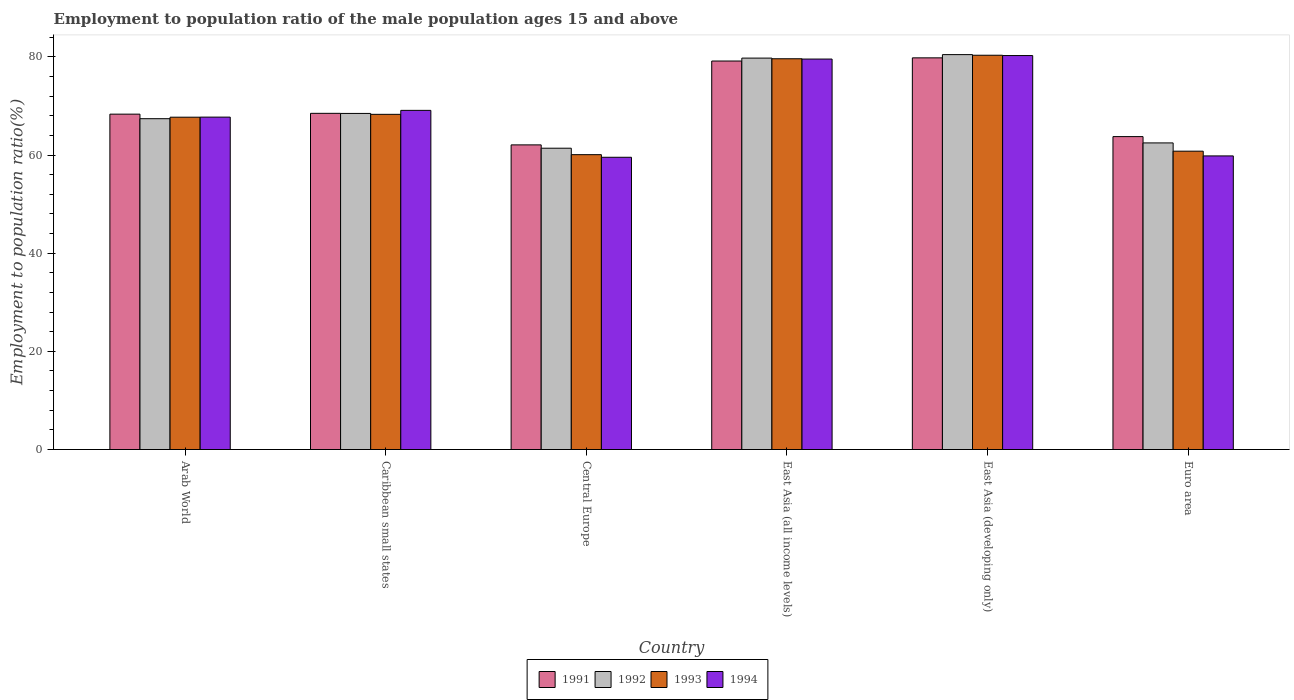Are the number of bars on each tick of the X-axis equal?
Offer a very short reply. Yes. How many bars are there on the 4th tick from the left?
Your answer should be very brief. 4. How many bars are there on the 5th tick from the right?
Your response must be concise. 4. What is the label of the 2nd group of bars from the left?
Your answer should be compact. Caribbean small states. In how many cases, is the number of bars for a given country not equal to the number of legend labels?
Your answer should be very brief. 0. What is the employment to population ratio in 1993 in Central Europe?
Keep it short and to the point. 60.07. Across all countries, what is the maximum employment to population ratio in 1992?
Your answer should be compact. 80.45. Across all countries, what is the minimum employment to population ratio in 1991?
Provide a succinct answer. 62.06. In which country was the employment to population ratio in 1992 maximum?
Make the answer very short. East Asia (developing only). In which country was the employment to population ratio in 1992 minimum?
Offer a terse response. Central Europe. What is the total employment to population ratio in 1993 in the graph?
Your answer should be compact. 416.77. What is the difference between the employment to population ratio in 1994 in Caribbean small states and that in Euro area?
Provide a succinct answer. 9.28. What is the difference between the employment to population ratio in 1994 in Euro area and the employment to population ratio in 1993 in Arab World?
Your answer should be compact. -7.89. What is the average employment to population ratio in 1991 per country?
Make the answer very short. 70.26. What is the difference between the employment to population ratio of/in 1993 and employment to population ratio of/in 1992 in East Asia (all income levels)?
Your response must be concise. -0.13. What is the ratio of the employment to population ratio in 1993 in Caribbean small states to that in Euro area?
Your answer should be compact. 1.12. Is the difference between the employment to population ratio in 1993 in Arab World and East Asia (developing only) greater than the difference between the employment to population ratio in 1992 in Arab World and East Asia (developing only)?
Offer a terse response. Yes. What is the difference between the highest and the second highest employment to population ratio in 1993?
Your answer should be compact. 12.04. What is the difference between the highest and the lowest employment to population ratio in 1991?
Offer a very short reply. 17.73. In how many countries, is the employment to population ratio in 1993 greater than the average employment to population ratio in 1993 taken over all countries?
Your answer should be very brief. 2. Is the sum of the employment to population ratio in 1994 in Arab World and Central Europe greater than the maximum employment to population ratio in 1993 across all countries?
Offer a very short reply. Yes. Is it the case that in every country, the sum of the employment to population ratio in 1994 and employment to population ratio in 1993 is greater than the sum of employment to population ratio in 1991 and employment to population ratio in 1992?
Your answer should be compact. No. What does the 1st bar from the left in East Asia (all income levels) represents?
Make the answer very short. 1991. How many bars are there?
Ensure brevity in your answer.  24. Are all the bars in the graph horizontal?
Give a very brief answer. No. How many countries are there in the graph?
Keep it short and to the point. 6. What is the difference between two consecutive major ticks on the Y-axis?
Make the answer very short. 20. Does the graph contain grids?
Provide a succinct answer. No. What is the title of the graph?
Offer a very short reply. Employment to population ratio of the male population ages 15 and above. What is the label or title of the X-axis?
Keep it short and to the point. Country. What is the label or title of the Y-axis?
Your answer should be compact. Employment to population ratio(%). What is the Employment to population ratio(%) in 1991 in Arab World?
Offer a terse response. 68.32. What is the Employment to population ratio(%) of 1992 in Arab World?
Offer a very short reply. 67.4. What is the Employment to population ratio(%) of 1993 in Arab World?
Give a very brief answer. 67.7. What is the Employment to population ratio(%) in 1994 in Arab World?
Your answer should be compact. 67.72. What is the Employment to population ratio(%) in 1991 in Caribbean small states?
Your answer should be very brief. 68.49. What is the Employment to population ratio(%) in 1992 in Caribbean small states?
Ensure brevity in your answer.  68.47. What is the Employment to population ratio(%) of 1993 in Caribbean small states?
Provide a succinct answer. 68.28. What is the Employment to population ratio(%) in 1994 in Caribbean small states?
Make the answer very short. 69.09. What is the Employment to population ratio(%) of 1991 in Central Europe?
Offer a very short reply. 62.06. What is the Employment to population ratio(%) in 1992 in Central Europe?
Offer a very short reply. 61.38. What is the Employment to population ratio(%) in 1993 in Central Europe?
Offer a very short reply. 60.07. What is the Employment to population ratio(%) of 1994 in Central Europe?
Keep it short and to the point. 59.54. What is the Employment to population ratio(%) of 1991 in East Asia (all income levels)?
Your response must be concise. 79.15. What is the Employment to population ratio(%) of 1992 in East Asia (all income levels)?
Make the answer very short. 79.74. What is the Employment to population ratio(%) of 1993 in East Asia (all income levels)?
Provide a succinct answer. 79.61. What is the Employment to population ratio(%) in 1994 in East Asia (all income levels)?
Give a very brief answer. 79.55. What is the Employment to population ratio(%) of 1991 in East Asia (developing only)?
Provide a succinct answer. 79.79. What is the Employment to population ratio(%) of 1992 in East Asia (developing only)?
Your response must be concise. 80.45. What is the Employment to population ratio(%) of 1993 in East Asia (developing only)?
Provide a succinct answer. 80.32. What is the Employment to population ratio(%) of 1994 in East Asia (developing only)?
Offer a very short reply. 80.26. What is the Employment to population ratio(%) of 1991 in Euro area?
Your answer should be very brief. 63.75. What is the Employment to population ratio(%) of 1992 in Euro area?
Your answer should be very brief. 62.46. What is the Employment to population ratio(%) of 1993 in Euro area?
Offer a very short reply. 60.78. What is the Employment to population ratio(%) of 1994 in Euro area?
Offer a terse response. 59.81. Across all countries, what is the maximum Employment to population ratio(%) of 1991?
Provide a succinct answer. 79.79. Across all countries, what is the maximum Employment to population ratio(%) in 1992?
Ensure brevity in your answer.  80.45. Across all countries, what is the maximum Employment to population ratio(%) of 1993?
Offer a very short reply. 80.32. Across all countries, what is the maximum Employment to population ratio(%) of 1994?
Make the answer very short. 80.26. Across all countries, what is the minimum Employment to population ratio(%) in 1991?
Give a very brief answer. 62.06. Across all countries, what is the minimum Employment to population ratio(%) of 1992?
Ensure brevity in your answer.  61.38. Across all countries, what is the minimum Employment to population ratio(%) of 1993?
Give a very brief answer. 60.07. Across all countries, what is the minimum Employment to population ratio(%) of 1994?
Your response must be concise. 59.54. What is the total Employment to population ratio(%) of 1991 in the graph?
Your response must be concise. 421.57. What is the total Employment to population ratio(%) of 1992 in the graph?
Your response must be concise. 419.91. What is the total Employment to population ratio(%) of 1993 in the graph?
Your answer should be compact. 416.77. What is the total Employment to population ratio(%) of 1994 in the graph?
Offer a very short reply. 415.97. What is the difference between the Employment to population ratio(%) of 1991 in Arab World and that in Caribbean small states?
Your response must be concise. -0.17. What is the difference between the Employment to population ratio(%) of 1992 in Arab World and that in Caribbean small states?
Provide a short and direct response. -1.07. What is the difference between the Employment to population ratio(%) in 1993 in Arab World and that in Caribbean small states?
Provide a succinct answer. -0.58. What is the difference between the Employment to population ratio(%) in 1994 in Arab World and that in Caribbean small states?
Your answer should be compact. -1.38. What is the difference between the Employment to population ratio(%) in 1991 in Arab World and that in Central Europe?
Ensure brevity in your answer.  6.26. What is the difference between the Employment to population ratio(%) of 1992 in Arab World and that in Central Europe?
Offer a terse response. 6.01. What is the difference between the Employment to population ratio(%) of 1993 in Arab World and that in Central Europe?
Your response must be concise. 7.63. What is the difference between the Employment to population ratio(%) in 1994 in Arab World and that in Central Europe?
Provide a short and direct response. 8.18. What is the difference between the Employment to population ratio(%) in 1991 in Arab World and that in East Asia (all income levels)?
Your answer should be very brief. -10.82. What is the difference between the Employment to population ratio(%) in 1992 in Arab World and that in East Asia (all income levels)?
Your response must be concise. -12.34. What is the difference between the Employment to population ratio(%) in 1993 in Arab World and that in East Asia (all income levels)?
Make the answer very short. -11.9. What is the difference between the Employment to population ratio(%) in 1994 in Arab World and that in East Asia (all income levels)?
Give a very brief answer. -11.83. What is the difference between the Employment to population ratio(%) of 1991 in Arab World and that in East Asia (developing only)?
Offer a very short reply. -11.47. What is the difference between the Employment to population ratio(%) of 1992 in Arab World and that in East Asia (developing only)?
Your answer should be very brief. -13.05. What is the difference between the Employment to population ratio(%) of 1993 in Arab World and that in East Asia (developing only)?
Provide a short and direct response. -12.62. What is the difference between the Employment to population ratio(%) of 1994 in Arab World and that in East Asia (developing only)?
Give a very brief answer. -12.54. What is the difference between the Employment to population ratio(%) of 1991 in Arab World and that in Euro area?
Your answer should be very brief. 4.58. What is the difference between the Employment to population ratio(%) in 1992 in Arab World and that in Euro area?
Your answer should be compact. 4.94. What is the difference between the Employment to population ratio(%) in 1993 in Arab World and that in Euro area?
Your answer should be compact. 6.92. What is the difference between the Employment to population ratio(%) of 1994 in Arab World and that in Euro area?
Give a very brief answer. 7.9. What is the difference between the Employment to population ratio(%) in 1991 in Caribbean small states and that in Central Europe?
Provide a succinct answer. 6.43. What is the difference between the Employment to population ratio(%) in 1992 in Caribbean small states and that in Central Europe?
Keep it short and to the point. 7.09. What is the difference between the Employment to population ratio(%) of 1993 in Caribbean small states and that in Central Europe?
Provide a succinct answer. 8.21. What is the difference between the Employment to population ratio(%) in 1994 in Caribbean small states and that in Central Europe?
Keep it short and to the point. 9.56. What is the difference between the Employment to population ratio(%) in 1991 in Caribbean small states and that in East Asia (all income levels)?
Keep it short and to the point. -10.66. What is the difference between the Employment to population ratio(%) of 1992 in Caribbean small states and that in East Asia (all income levels)?
Give a very brief answer. -11.27. What is the difference between the Employment to population ratio(%) in 1993 in Caribbean small states and that in East Asia (all income levels)?
Offer a very short reply. -11.32. What is the difference between the Employment to population ratio(%) of 1994 in Caribbean small states and that in East Asia (all income levels)?
Offer a very short reply. -10.45. What is the difference between the Employment to population ratio(%) in 1991 in Caribbean small states and that in East Asia (developing only)?
Keep it short and to the point. -11.3. What is the difference between the Employment to population ratio(%) in 1992 in Caribbean small states and that in East Asia (developing only)?
Give a very brief answer. -11.98. What is the difference between the Employment to population ratio(%) of 1993 in Caribbean small states and that in East Asia (developing only)?
Make the answer very short. -12.04. What is the difference between the Employment to population ratio(%) of 1994 in Caribbean small states and that in East Asia (developing only)?
Ensure brevity in your answer.  -11.17. What is the difference between the Employment to population ratio(%) in 1991 in Caribbean small states and that in Euro area?
Make the answer very short. 4.74. What is the difference between the Employment to population ratio(%) in 1992 in Caribbean small states and that in Euro area?
Offer a very short reply. 6.01. What is the difference between the Employment to population ratio(%) in 1993 in Caribbean small states and that in Euro area?
Offer a very short reply. 7.5. What is the difference between the Employment to population ratio(%) in 1994 in Caribbean small states and that in Euro area?
Your answer should be compact. 9.28. What is the difference between the Employment to population ratio(%) of 1991 in Central Europe and that in East Asia (all income levels)?
Offer a very short reply. -17.08. What is the difference between the Employment to population ratio(%) in 1992 in Central Europe and that in East Asia (all income levels)?
Your response must be concise. -18.36. What is the difference between the Employment to population ratio(%) of 1993 in Central Europe and that in East Asia (all income levels)?
Your response must be concise. -19.54. What is the difference between the Employment to population ratio(%) in 1994 in Central Europe and that in East Asia (all income levels)?
Your response must be concise. -20.01. What is the difference between the Employment to population ratio(%) in 1991 in Central Europe and that in East Asia (developing only)?
Give a very brief answer. -17.73. What is the difference between the Employment to population ratio(%) in 1992 in Central Europe and that in East Asia (developing only)?
Your response must be concise. -19.07. What is the difference between the Employment to population ratio(%) of 1993 in Central Europe and that in East Asia (developing only)?
Make the answer very short. -20.25. What is the difference between the Employment to population ratio(%) of 1994 in Central Europe and that in East Asia (developing only)?
Make the answer very short. -20.72. What is the difference between the Employment to population ratio(%) in 1991 in Central Europe and that in Euro area?
Keep it short and to the point. -1.69. What is the difference between the Employment to population ratio(%) of 1992 in Central Europe and that in Euro area?
Give a very brief answer. -1.08. What is the difference between the Employment to population ratio(%) of 1993 in Central Europe and that in Euro area?
Make the answer very short. -0.71. What is the difference between the Employment to population ratio(%) of 1994 in Central Europe and that in Euro area?
Make the answer very short. -0.28. What is the difference between the Employment to population ratio(%) in 1991 in East Asia (all income levels) and that in East Asia (developing only)?
Offer a terse response. -0.65. What is the difference between the Employment to population ratio(%) of 1992 in East Asia (all income levels) and that in East Asia (developing only)?
Provide a short and direct response. -0.71. What is the difference between the Employment to population ratio(%) of 1993 in East Asia (all income levels) and that in East Asia (developing only)?
Provide a succinct answer. -0.72. What is the difference between the Employment to population ratio(%) in 1994 in East Asia (all income levels) and that in East Asia (developing only)?
Offer a very short reply. -0.71. What is the difference between the Employment to population ratio(%) of 1991 in East Asia (all income levels) and that in Euro area?
Your response must be concise. 15.4. What is the difference between the Employment to population ratio(%) of 1992 in East Asia (all income levels) and that in Euro area?
Offer a very short reply. 17.28. What is the difference between the Employment to population ratio(%) in 1993 in East Asia (all income levels) and that in Euro area?
Give a very brief answer. 18.83. What is the difference between the Employment to population ratio(%) in 1994 in East Asia (all income levels) and that in Euro area?
Your response must be concise. 19.73. What is the difference between the Employment to population ratio(%) in 1991 in East Asia (developing only) and that in Euro area?
Offer a terse response. 16.05. What is the difference between the Employment to population ratio(%) of 1992 in East Asia (developing only) and that in Euro area?
Give a very brief answer. 17.99. What is the difference between the Employment to population ratio(%) in 1993 in East Asia (developing only) and that in Euro area?
Ensure brevity in your answer.  19.54. What is the difference between the Employment to population ratio(%) in 1994 in East Asia (developing only) and that in Euro area?
Your response must be concise. 20.45. What is the difference between the Employment to population ratio(%) of 1991 in Arab World and the Employment to population ratio(%) of 1992 in Caribbean small states?
Offer a terse response. -0.15. What is the difference between the Employment to population ratio(%) in 1991 in Arab World and the Employment to population ratio(%) in 1993 in Caribbean small states?
Ensure brevity in your answer.  0.04. What is the difference between the Employment to population ratio(%) in 1991 in Arab World and the Employment to population ratio(%) in 1994 in Caribbean small states?
Ensure brevity in your answer.  -0.77. What is the difference between the Employment to population ratio(%) of 1992 in Arab World and the Employment to population ratio(%) of 1993 in Caribbean small states?
Ensure brevity in your answer.  -0.89. What is the difference between the Employment to population ratio(%) in 1992 in Arab World and the Employment to population ratio(%) in 1994 in Caribbean small states?
Your response must be concise. -1.7. What is the difference between the Employment to population ratio(%) of 1993 in Arab World and the Employment to population ratio(%) of 1994 in Caribbean small states?
Your answer should be very brief. -1.39. What is the difference between the Employment to population ratio(%) in 1991 in Arab World and the Employment to population ratio(%) in 1992 in Central Europe?
Your response must be concise. 6.94. What is the difference between the Employment to population ratio(%) in 1991 in Arab World and the Employment to population ratio(%) in 1993 in Central Europe?
Ensure brevity in your answer.  8.25. What is the difference between the Employment to population ratio(%) in 1991 in Arab World and the Employment to population ratio(%) in 1994 in Central Europe?
Ensure brevity in your answer.  8.79. What is the difference between the Employment to population ratio(%) in 1992 in Arab World and the Employment to population ratio(%) in 1993 in Central Europe?
Offer a very short reply. 7.33. What is the difference between the Employment to population ratio(%) of 1992 in Arab World and the Employment to population ratio(%) of 1994 in Central Europe?
Provide a succinct answer. 7.86. What is the difference between the Employment to population ratio(%) of 1993 in Arab World and the Employment to population ratio(%) of 1994 in Central Europe?
Offer a very short reply. 8.17. What is the difference between the Employment to population ratio(%) of 1991 in Arab World and the Employment to population ratio(%) of 1992 in East Asia (all income levels)?
Keep it short and to the point. -11.42. What is the difference between the Employment to population ratio(%) of 1991 in Arab World and the Employment to population ratio(%) of 1993 in East Asia (all income levels)?
Your answer should be compact. -11.28. What is the difference between the Employment to population ratio(%) of 1991 in Arab World and the Employment to population ratio(%) of 1994 in East Asia (all income levels)?
Provide a short and direct response. -11.22. What is the difference between the Employment to population ratio(%) in 1992 in Arab World and the Employment to population ratio(%) in 1993 in East Asia (all income levels)?
Your answer should be very brief. -12.21. What is the difference between the Employment to population ratio(%) in 1992 in Arab World and the Employment to population ratio(%) in 1994 in East Asia (all income levels)?
Provide a short and direct response. -12.15. What is the difference between the Employment to population ratio(%) in 1993 in Arab World and the Employment to population ratio(%) in 1994 in East Asia (all income levels)?
Your answer should be very brief. -11.84. What is the difference between the Employment to population ratio(%) in 1991 in Arab World and the Employment to population ratio(%) in 1992 in East Asia (developing only)?
Your response must be concise. -12.13. What is the difference between the Employment to population ratio(%) of 1991 in Arab World and the Employment to population ratio(%) of 1993 in East Asia (developing only)?
Ensure brevity in your answer.  -12. What is the difference between the Employment to population ratio(%) of 1991 in Arab World and the Employment to population ratio(%) of 1994 in East Asia (developing only)?
Ensure brevity in your answer.  -11.94. What is the difference between the Employment to population ratio(%) of 1992 in Arab World and the Employment to population ratio(%) of 1993 in East Asia (developing only)?
Keep it short and to the point. -12.93. What is the difference between the Employment to population ratio(%) in 1992 in Arab World and the Employment to population ratio(%) in 1994 in East Asia (developing only)?
Provide a short and direct response. -12.86. What is the difference between the Employment to population ratio(%) of 1993 in Arab World and the Employment to population ratio(%) of 1994 in East Asia (developing only)?
Your answer should be compact. -12.56. What is the difference between the Employment to population ratio(%) in 1991 in Arab World and the Employment to population ratio(%) in 1992 in Euro area?
Your answer should be compact. 5.86. What is the difference between the Employment to population ratio(%) of 1991 in Arab World and the Employment to population ratio(%) of 1993 in Euro area?
Keep it short and to the point. 7.54. What is the difference between the Employment to population ratio(%) in 1991 in Arab World and the Employment to population ratio(%) in 1994 in Euro area?
Give a very brief answer. 8.51. What is the difference between the Employment to population ratio(%) in 1992 in Arab World and the Employment to population ratio(%) in 1993 in Euro area?
Ensure brevity in your answer.  6.62. What is the difference between the Employment to population ratio(%) in 1992 in Arab World and the Employment to population ratio(%) in 1994 in Euro area?
Offer a very short reply. 7.58. What is the difference between the Employment to population ratio(%) in 1993 in Arab World and the Employment to population ratio(%) in 1994 in Euro area?
Offer a terse response. 7.89. What is the difference between the Employment to population ratio(%) of 1991 in Caribbean small states and the Employment to population ratio(%) of 1992 in Central Europe?
Offer a very short reply. 7.11. What is the difference between the Employment to population ratio(%) in 1991 in Caribbean small states and the Employment to population ratio(%) in 1993 in Central Europe?
Your response must be concise. 8.42. What is the difference between the Employment to population ratio(%) of 1991 in Caribbean small states and the Employment to population ratio(%) of 1994 in Central Europe?
Your answer should be very brief. 8.95. What is the difference between the Employment to population ratio(%) of 1992 in Caribbean small states and the Employment to population ratio(%) of 1993 in Central Europe?
Your answer should be very brief. 8.4. What is the difference between the Employment to population ratio(%) of 1992 in Caribbean small states and the Employment to population ratio(%) of 1994 in Central Europe?
Ensure brevity in your answer.  8.93. What is the difference between the Employment to population ratio(%) in 1993 in Caribbean small states and the Employment to population ratio(%) in 1994 in Central Europe?
Keep it short and to the point. 8.75. What is the difference between the Employment to population ratio(%) in 1991 in Caribbean small states and the Employment to population ratio(%) in 1992 in East Asia (all income levels)?
Your response must be concise. -11.25. What is the difference between the Employment to population ratio(%) of 1991 in Caribbean small states and the Employment to population ratio(%) of 1993 in East Asia (all income levels)?
Give a very brief answer. -11.12. What is the difference between the Employment to population ratio(%) of 1991 in Caribbean small states and the Employment to population ratio(%) of 1994 in East Asia (all income levels)?
Make the answer very short. -11.06. What is the difference between the Employment to population ratio(%) of 1992 in Caribbean small states and the Employment to population ratio(%) of 1993 in East Asia (all income levels)?
Make the answer very short. -11.14. What is the difference between the Employment to population ratio(%) of 1992 in Caribbean small states and the Employment to population ratio(%) of 1994 in East Asia (all income levels)?
Offer a terse response. -11.08. What is the difference between the Employment to population ratio(%) of 1993 in Caribbean small states and the Employment to population ratio(%) of 1994 in East Asia (all income levels)?
Keep it short and to the point. -11.26. What is the difference between the Employment to population ratio(%) in 1991 in Caribbean small states and the Employment to population ratio(%) in 1992 in East Asia (developing only)?
Provide a short and direct response. -11.96. What is the difference between the Employment to population ratio(%) in 1991 in Caribbean small states and the Employment to population ratio(%) in 1993 in East Asia (developing only)?
Ensure brevity in your answer.  -11.83. What is the difference between the Employment to population ratio(%) of 1991 in Caribbean small states and the Employment to population ratio(%) of 1994 in East Asia (developing only)?
Offer a very short reply. -11.77. What is the difference between the Employment to population ratio(%) in 1992 in Caribbean small states and the Employment to population ratio(%) in 1993 in East Asia (developing only)?
Your response must be concise. -11.85. What is the difference between the Employment to population ratio(%) in 1992 in Caribbean small states and the Employment to population ratio(%) in 1994 in East Asia (developing only)?
Provide a short and direct response. -11.79. What is the difference between the Employment to population ratio(%) in 1993 in Caribbean small states and the Employment to population ratio(%) in 1994 in East Asia (developing only)?
Make the answer very short. -11.98. What is the difference between the Employment to population ratio(%) in 1991 in Caribbean small states and the Employment to population ratio(%) in 1992 in Euro area?
Your answer should be very brief. 6.03. What is the difference between the Employment to population ratio(%) of 1991 in Caribbean small states and the Employment to population ratio(%) of 1993 in Euro area?
Offer a very short reply. 7.71. What is the difference between the Employment to population ratio(%) in 1991 in Caribbean small states and the Employment to population ratio(%) in 1994 in Euro area?
Offer a very short reply. 8.68. What is the difference between the Employment to population ratio(%) of 1992 in Caribbean small states and the Employment to population ratio(%) of 1993 in Euro area?
Your answer should be very brief. 7.69. What is the difference between the Employment to population ratio(%) in 1992 in Caribbean small states and the Employment to population ratio(%) in 1994 in Euro area?
Your response must be concise. 8.66. What is the difference between the Employment to population ratio(%) of 1993 in Caribbean small states and the Employment to population ratio(%) of 1994 in Euro area?
Make the answer very short. 8.47. What is the difference between the Employment to population ratio(%) in 1991 in Central Europe and the Employment to population ratio(%) in 1992 in East Asia (all income levels)?
Offer a terse response. -17.68. What is the difference between the Employment to population ratio(%) of 1991 in Central Europe and the Employment to population ratio(%) of 1993 in East Asia (all income levels)?
Provide a succinct answer. -17.55. What is the difference between the Employment to population ratio(%) of 1991 in Central Europe and the Employment to population ratio(%) of 1994 in East Asia (all income levels)?
Provide a succinct answer. -17.49. What is the difference between the Employment to population ratio(%) in 1992 in Central Europe and the Employment to population ratio(%) in 1993 in East Asia (all income levels)?
Offer a terse response. -18.22. What is the difference between the Employment to population ratio(%) of 1992 in Central Europe and the Employment to population ratio(%) of 1994 in East Asia (all income levels)?
Make the answer very short. -18.16. What is the difference between the Employment to population ratio(%) in 1993 in Central Europe and the Employment to population ratio(%) in 1994 in East Asia (all income levels)?
Your answer should be compact. -19.48. What is the difference between the Employment to population ratio(%) of 1991 in Central Europe and the Employment to population ratio(%) of 1992 in East Asia (developing only)?
Give a very brief answer. -18.39. What is the difference between the Employment to population ratio(%) in 1991 in Central Europe and the Employment to population ratio(%) in 1993 in East Asia (developing only)?
Ensure brevity in your answer.  -18.26. What is the difference between the Employment to population ratio(%) in 1991 in Central Europe and the Employment to population ratio(%) in 1994 in East Asia (developing only)?
Ensure brevity in your answer.  -18.2. What is the difference between the Employment to population ratio(%) in 1992 in Central Europe and the Employment to population ratio(%) in 1993 in East Asia (developing only)?
Give a very brief answer. -18.94. What is the difference between the Employment to population ratio(%) in 1992 in Central Europe and the Employment to population ratio(%) in 1994 in East Asia (developing only)?
Keep it short and to the point. -18.88. What is the difference between the Employment to population ratio(%) of 1993 in Central Europe and the Employment to population ratio(%) of 1994 in East Asia (developing only)?
Your answer should be compact. -20.19. What is the difference between the Employment to population ratio(%) of 1991 in Central Europe and the Employment to population ratio(%) of 1992 in Euro area?
Offer a terse response. -0.4. What is the difference between the Employment to population ratio(%) in 1991 in Central Europe and the Employment to population ratio(%) in 1993 in Euro area?
Offer a very short reply. 1.28. What is the difference between the Employment to population ratio(%) in 1991 in Central Europe and the Employment to population ratio(%) in 1994 in Euro area?
Give a very brief answer. 2.25. What is the difference between the Employment to population ratio(%) in 1992 in Central Europe and the Employment to population ratio(%) in 1993 in Euro area?
Give a very brief answer. 0.6. What is the difference between the Employment to population ratio(%) in 1992 in Central Europe and the Employment to population ratio(%) in 1994 in Euro area?
Offer a very short reply. 1.57. What is the difference between the Employment to population ratio(%) of 1993 in Central Europe and the Employment to population ratio(%) of 1994 in Euro area?
Ensure brevity in your answer.  0.26. What is the difference between the Employment to population ratio(%) of 1991 in East Asia (all income levels) and the Employment to population ratio(%) of 1992 in East Asia (developing only)?
Offer a very short reply. -1.3. What is the difference between the Employment to population ratio(%) of 1991 in East Asia (all income levels) and the Employment to population ratio(%) of 1993 in East Asia (developing only)?
Give a very brief answer. -1.18. What is the difference between the Employment to population ratio(%) in 1991 in East Asia (all income levels) and the Employment to population ratio(%) in 1994 in East Asia (developing only)?
Your response must be concise. -1.11. What is the difference between the Employment to population ratio(%) in 1992 in East Asia (all income levels) and the Employment to population ratio(%) in 1993 in East Asia (developing only)?
Your answer should be very brief. -0.58. What is the difference between the Employment to population ratio(%) of 1992 in East Asia (all income levels) and the Employment to population ratio(%) of 1994 in East Asia (developing only)?
Offer a very short reply. -0.52. What is the difference between the Employment to population ratio(%) of 1993 in East Asia (all income levels) and the Employment to population ratio(%) of 1994 in East Asia (developing only)?
Keep it short and to the point. -0.65. What is the difference between the Employment to population ratio(%) of 1991 in East Asia (all income levels) and the Employment to population ratio(%) of 1992 in Euro area?
Keep it short and to the point. 16.68. What is the difference between the Employment to population ratio(%) of 1991 in East Asia (all income levels) and the Employment to population ratio(%) of 1993 in Euro area?
Offer a terse response. 18.37. What is the difference between the Employment to population ratio(%) of 1991 in East Asia (all income levels) and the Employment to population ratio(%) of 1994 in Euro area?
Offer a terse response. 19.33. What is the difference between the Employment to population ratio(%) in 1992 in East Asia (all income levels) and the Employment to population ratio(%) in 1993 in Euro area?
Provide a short and direct response. 18.96. What is the difference between the Employment to population ratio(%) of 1992 in East Asia (all income levels) and the Employment to population ratio(%) of 1994 in Euro area?
Your answer should be very brief. 19.93. What is the difference between the Employment to population ratio(%) in 1993 in East Asia (all income levels) and the Employment to population ratio(%) in 1994 in Euro area?
Provide a succinct answer. 19.79. What is the difference between the Employment to population ratio(%) of 1991 in East Asia (developing only) and the Employment to population ratio(%) of 1992 in Euro area?
Provide a short and direct response. 17.33. What is the difference between the Employment to population ratio(%) of 1991 in East Asia (developing only) and the Employment to population ratio(%) of 1993 in Euro area?
Offer a very short reply. 19.01. What is the difference between the Employment to population ratio(%) in 1991 in East Asia (developing only) and the Employment to population ratio(%) in 1994 in Euro area?
Give a very brief answer. 19.98. What is the difference between the Employment to population ratio(%) in 1992 in East Asia (developing only) and the Employment to population ratio(%) in 1993 in Euro area?
Ensure brevity in your answer.  19.67. What is the difference between the Employment to population ratio(%) of 1992 in East Asia (developing only) and the Employment to population ratio(%) of 1994 in Euro area?
Give a very brief answer. 20.64. What is the difference between the Employment to population ratio(%) in 1993 in East Asia (developing only) and the Employment to population ratio(%) in 1994 in Euro area?
Offer a terse response. 20.51. What is the average Employment to population ratio(%) of 1991 per country?
Keep it short and to the point. 70.26. What is the average Employment to population ratio(%) of 1992 per country?
Give a very brief answer. 69.98. What is the average Employment to population ratio(%) in 1993 per country?
Ensure brevity in your answer.  69.46. What is the average Employment to population ratio(%) in 1994 per country?
Offer a terse response. 69.33. What is the difference between the Employment to population ratio(%) of 1991 and Employment to population ratio(%) of 1992 in Arab World?
Make the answer very short. 0.93. What is the difference between the Employment to population ratio(%) of 1991 and Employment to population ratio(%) of 1993 in Arab World?
Offer a terse response. 0.62. What is the difference between the Employment to population ratio(%) in 1991 and Employment to population ratio(%) in 1994 in Arab World?
Ensure brevity in your answer.  0.61. What is the difference between the Employment to population ratio(%) in 1992 and Employment to population ratio(%) in 1993 in Arab World?
Make the answer very short. -0.31. What is the difference between the Employment to population ratio(%) in 1992 and Employment to population ratio(%) in 1994 in Arab World?
Your answer should be compact. -0.32. What is the difference between the Employment to population ratio(%) of 1993 and Employment to population ratio(%) of 1994 in Arab World?
Your response must be concise. -0.01. What is the difference between the Employment to population ratio(%) of 1991 and Employment to population ratio(%) of 1992 in Caribbean small states?
Offer a very short reply. 0.02. What is the difference between the Employment to population ratio(%) in 1991 and Employment to population ratio(%) in 1993 in Caribbean small states?
Keep it short and to the point. 0.21. What is the difference between the Employment to population ratio(%) in 1991 and Employment to population ratio(%) in 1994 in Caribbean small states?
Ensure brevity in your answer.  -0.6. What is the difference between the Employment to population ratio(%) in 1992 and Employment to population ratio(%) in 1993 in Caribbean small states?
Offer a terse response. 0.19. What is the difference between the Employment to population ratio(%) of 1992 and Employment to population ratio(%) of 1994 in Caribbean small states?
Ensure brevity in your answer.  -0.62. What is the difference between the Employment to population ratio(%) of 1993 and Employment to population ratio(%) of 1994 in Caribbean small states?
Offer a terse response. -0.81. What is the difference between the Employment to population ratio(%) in 1991 and Employment to population ratio(%) in 1992 in Central Europe?
Provide a short and direct response. 0.68. What is the difference between the Employment to population ratio(%) in 1991 and Employment to population ratio(%) in 1993 in Central Europe?
Provide a short and direct response. 1.99. What is the difference between the Employment to population ratio(%) in 1991 and Employment to population ratio(%) in 1994 in Central Europe?
Your answer should be very brief. 2.52. What is the difference between the Employment to population ratio(%) of 1992 and Employment to population ratio(%) of 1993 in Central Europe?
Ensure brevity in your answer.  1.31. What is the difference between the Employment to population ratio(%) in 1992 and Employment to population ratio(%) in 1994 in Central Europe?
Offer a terse response. 1.85. What is the difference between the Employment to population ratio(%) in 1993 and Employment to population ratio(%) in 1994 in Central Europe?
Your answer should be compact. 0.53. What is the difference between the Employment to population ratio(%) in 1991 and Employment to population ratio(%) in 1992 in East Asia (all income levels)?
Offer a terse response. -0.59. What is the difference between the Employment to population ratio(%) of 1991 and Employment to population ratio(%) of 1993 in East Asia (all income levels)?
Keep it short and to the point. -0.46. What is the difference between the Employment to population ratio(%) in 1991 and Employment to population ratio(%) in 1994 in East Asia (all income levels)?
Give a very brief answer. -0.4. What is the difference between the Employment to population ratio(%) in 1992 and Employment to population ratio(%) in 1993 in East Asia (all income levels)?
Make the answer very short. 0.13. What is the difference between the Employment to population ratio(%) in 1992 and Employment to population ratio(%) in 1994 in East Asia (all income levels)?
Your response must be concise. 0.19. What is the difference between the Employment to population ratio(%) of 1993 and Employment to population ratio(%) of 1994 in East Asia (all income levels)?
Your answer should be compact. 0.06. What is the difference between the Employment to population ratio(%) of 1991 and Employment to population ratio(%) of 1992 in East Asia (developing only)?
Offer a very short reply. -0.66. What is the difference between the Employment to population ratio(%) in 1991 and Employment to population ratio(%) in 1993 in East Asia (developing only)?
Offer a terse response. -0.53. What is the difference between the Employment to population ratio(%) in 1991 and Employment to population ratio(%) in 1994 in East Asia (developing only)?
Provide a succinct answer. -0.47. What is the difference between the Employment to population ratio(%) of 1992 and Employment to population ratio(%) of 1993 in East Asia (developing only)?
Give a very brief answer. 0.13. What is the difference between the Employment to population ratio(%) of 1992 and Employment to population ratio(%) of 1994 in East Asia (developing only)?
Your response must be concise. 0.19. What is the difference between the Employment to population ratio(%) in 1993 and Employment to population ratio(%) in 1994 in East Asia (developing only)?
Give a very brief answer. 0.06. What is the difference between the Employment to population ratio(%) in 1991 and Employment to population ratio(%) in 1992 in Euro area?
Provide a short and direct response. 1.29. What is the difference between the Employment to population ratio(%) in 1991 and Employment to population ratio(%) in 1993 in Euro area?
Offer a very short reply. 2.97. What is the difference between the Employment to population ratio(%) in 1991 and Employment to population ratio(%) in 1994 in Euro area?
Keep it short and to the point. 3.93. What is the difference between the Employment to population ratio(%) in 1992 and Employment to population ratio(%) in 1993 in Euro area?
Your answer should be very brief. 1.68. What is the difference between the Employment to population ratio(%) of 1992 and Employment to population ratio(%) of 1994 in Euro area?
Your response must be concise. 2.65. What is the difference between the Employment to population ratio(%) in 1993 and Employment to population ratio(%) in 1994 in Euro area?
Keep it short and to the point. 0.97. What is the ratio of the Employment to population ratio(%) in 1991 in Arab World to that in Caribbean small states?
Offer a very short reply. 1. What is the ratio of the Employment to population ratio(%) of 1992 in Arab World to that in Caribbean small states?
Offer a very short reply. 0.98. What is the ratio of the Employment to population ratio(%) in 1993 in Arab World to that in Caribbean small states?
Your response must be concise. 0.99. What is the ratio of the Employment to population ratio(%) of 1994 in Arab World to that in Caribbean small states?
Your answer should be very brief. 0.98. What is the ratio of the Employment to population ratio(%) of 1991 in Arab World to that in Central Europe?
Ensure brevity in your answer.  1.1. What is the ratio of the Employment to population ratio(%) in 1992 in Arab World to that in Central Europe?
Your answer should be very brief. 1.1. What is the ratio of the Employment to population ratio(%) in 1993 in Arab World to that in Central Europe?
Provide a succinct answer. 1.13. What is the ratio of the Employment to population ratio(%) in 1994 in Arab World to that in Central Europe?
Ensure brevity in your answer.  1.14. What is the ratio of the Employment to population ratio(%) in 1991 in Arab World to that in East Asia (all income levels)?
Your response must be concise. 0.86. What is the ratio of the Employment to population ratio(%) in 1992 in Arab World to that in East Asia (all income levels)?
Your response must be concise. 0.85. What is the ratio of the Employment to population ratio(%) of 1993 in Arab World to that in East Asia (all income levels)?
Your answer should be very brief. 0.85. What is the ratio of the Employment to population ratio(%) in 1994 in Arab World to that in East Asia (all income levels)?
Provide a succinct answer. 0.85. What is the ratio of the Employment to population ratio(%) in 1991 in Arab World to that in East Asia (developing only)?
Give a very brief answer. 0.86. What is the ratio of the Employment to population ratio(%) in 1992 in Arab World to that in East Asia (developing only)?
Offer a very short reply. 0.84. What is the ratio of the Employment to population ratio(%) of 1993 in Arab World to that in East Asia (developing only)?
Make the answer very short. 0.84. What is the ratio of the Employment to population ratio(%) of 1994 in Arab World to that in East Asia (developing only)?
Make the answer very short. 0.84. What is the ratio of the Employment to population ratio(%) in 1991 in Arab World to that in Euro area?
Your answer should be compact. 1.07. What is the ratio of the Employment to population ratio(%) in 1992 in Arab World to that in Euro area?
Offer a very short reply. 1.08. What is the ratio of the Employment to population ratio(%) of 1993 in Arab World to that in Euro area?
Ensure brevity in your answer.  1.11. What is the ratio of the Employment to population ratio(%) of 1994 in Arab World to that in Euro area?
Ensure brevity in your answer.  1.13. What is the ratio of the Employment to population ratio(%) in 1991 in Caribbean small states to that in Central Europe?
Offer a very short reply. 1.1. What is the ratio of the Employment to population ratio(%) of 1992 in Caribbean small states to that in Central Europe?
Offer a very short reply. 1.12. What is the ratio of the Employment to population ratio(%) in 1993 in Caribbean small states to that in Central Europe?
Offer a terse response. 1.14. What is the ratio of the Employment to population ratio(%) in 1994 in Caribbean small states to that in Central Europe?
Make the answer very short. 1.16. What is the ratio of the Employment to population ratio(%) of 1991 in Caribbean small states to that in East Asia (all income levels)?
Provide a succinct answer. 0.87. What is the ratio of the Employment to population ratio(%) of 1992 in Caribbean small states to that in East Asia (all income levels)?
Give a very brief answer. 0.86. What is the ratio of the Employment to population ratio(%) in 1993 in Caribbean small states to that in East Asia (all income levels)?
Keep it short and to the point. 0.86. What is the ratio of the Employment to population ratio(%) in 1994 in Caribbean small states to that in East Asia (all income levels)?
Offer a terse response. 0.87. What is the ratio of the Employment to population ratio(%) in 1991 in Caribbean small states to that in East Asia (developing only)?
Your response must be concise. 0.86. What is the ratio of the Employment to population ratio(%) in 1992 in Caribbean small states to that in East Asia (developing only)?
Provide a succinct answer. 0.85. What is the ratio of the Employment to population ratio(%) in 1993 in Caribbean small states to that in East Asia (developing only)?
Give a very brief answer. 0.85. What is the ratio of the Employment to population ratio(%) of 1994 in Caribbean small states to that in East Asia (developing only)?
Offer a very short reply. 0.86. What is the ratio of the Employment to population ratio(%) of 1991 in Caribbean small states to that in Euro area?
Offer a very short reply. 1.07. What is the ratio of the Employment to population ratio(%) of 1992 in Caribbean small states to that in Euro area?
Provide a short and direct response. 1.1. What is the ratio of the Employment to population ratio(%) in 1993 in Caribbean small states to that in Euro area?
Your answer should be very brief. 1.12. What is the ratio of the Employment to population ratio(%) in 1994 in Caribbean small states to that in Euro area?
Ensure brevity in your answer.  1.16. What is the ratio of the Employment to population ratio(%) of 1991 in Central Europe to that in East Asia (all income levels)?
Offer a very short reply. 0.78. What is the ratio of the Employment to population ratio(%) of 1992 in Central Europe to that in East Asia (all income levels)?
Your answer should be compact. 0.77. What is the ratio of the Employment to population ratio(%) in 1993 in Central Europe to that in East Asia (all income levels)?
Your answer should be very brief. 0.75. What is the ratio of the Employment to population ratio(%) in 1994 in Central Europe to that in East Asia (all income levels)?
Offer a terse response. 0.75. What is the ratio of the Employment to population ratio(%) of 1991 in Central Europe to that in East Asia (developing only)?
Your answer should be very brief. 0.78. What is the ratio of the Employment to population ratio(%) of 1992 in Central Europe to that in East Asia (developing only)?
Your answer should be very brief. 0.76. What is the ratio of the Employment to population ratio(%) of 1993 in Central Europe to that in East Asia (developing only)?
Keep it short and to the point. 0.75. What is the ratio of the Employment to population ratio(%) of 1994 in Central Europe to that in East Asia (developing only)?
Ensure brevity in your answer.  0.74. What is the ratio of the Employment to population ratio(%) of 1991 in Central Europe to that in Euro area?
Ensure brevity in your answer.  0.97. What is the ratio of the Employment to population ratio(%) in 1992 in Central Europe to that in Euro area?
Provide a succinct answer. 0.98. What is the ratio of the Employment to population ratio(%) in 1993 in Central Europe to that in Euro area?
Make the answer very short. 0.99. What is the ratio of the Employment to population ratio(%) of 1994 in Central Europe to that in Euro area?
Offer a terse response. 1. What is the ratio of the Employment to population ratio(%) of 1991 in East Asia (all income levels) to that in East Asia (developing only)?
Provide a succinct answer. 0.99. What is the ratio of the Employment to population ratio(%) in 1993 in East Asia (all income levels) to that in East Asia (developing only)?
Make the answer very short. 0.99. What is the ratio of the Employment to population ratio(%) of 1994 in East Asia (all income levels) to that in East Asia (developing only)?
Make the answer very short. 0.99. What is the ratio of the Employment to population ratio(%) in 1991 in East Asia (all income levels) to that in Euro area?
Offer a terse response. 1.24. What is the ratio of the Employment to population ratio(%) of 1992 in East Asia (all income levels) to that in Euro area?
Ensure brevity in your answer.  1.28. What is the ratio of the Employment to population ratio(%) in 1993 in East Asia (all income levels) to that in Euro area?
Keep it short and to the point. 1.31. What is the ratio of the Employment to population ratio(%) of 1994 in East Asia (all income levels) to that in Euro area?
Your response must be concise. 1.33. What is the ratio of the Employment to population ratio(%) of 1991 in East Asia (developing only) to that in Euro area?
Provide a succinct answer. 1.25. What is the ratio of the Employment to population ratio(%) of 1992 in East Asia (developing only) to that in Euro area?
Your answer should be compact. 1.29. What is the ratio of the Employment to population ratio(%) in 1993 in East Asia (developing only) to that in Euro area?
Make the answer very short. 1.32. What is the ratio of the Employment to population ratio(%) of 1994 in East Asia (developing only) to that in Euro area?
Offer a terse response. 1.34. What is the difference between the highest and the second highest Employment to population ratio(%) in 1991?
Provide a succinct answer. 0.65. What is the difference between the highest and the second highest Employment to population ratio(%) of 1992?
Keep it short and to the point. 0.71. What is the difference between the highest and the second highest Employment to population ratio(%) in 1993?
Make the answer very short. 0.72. What is the difference between the highest and the second highest Employment to population ratio(%) of 1994?
Give a very brief answer. 0.71. What is the difference between the highest and the lowest Employment to population ratio(%) of 1991?
Ensure brevity in your answer.  17.73. What is the difference between the highest and the lowest Employment to population ratio(%) in 1992?
Ensure brevity in your answer.  19.07. What is the difference between the highest and the lowest Employment to population ratio(%) of 1993?
Provide a short and direct response. 20.25. What is the difference between the highest and the lowest Employment to population ratio(%) of 1994?
Your response must be concise. 20.72. 